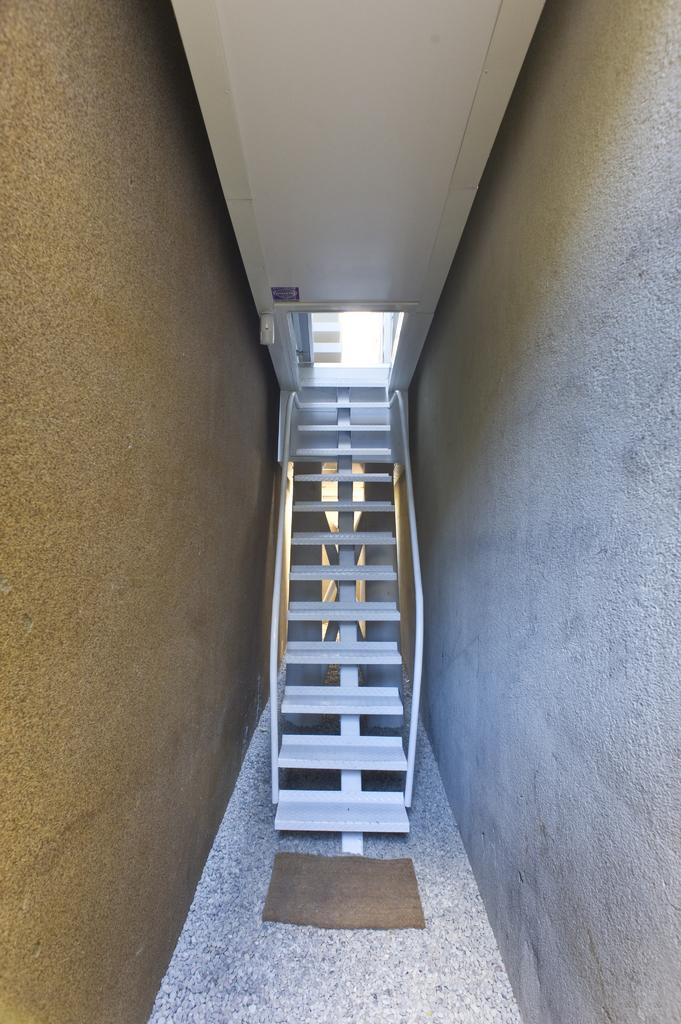Can you describe this image briefly? In this image, we can see stairs and in the background, there is wall. 